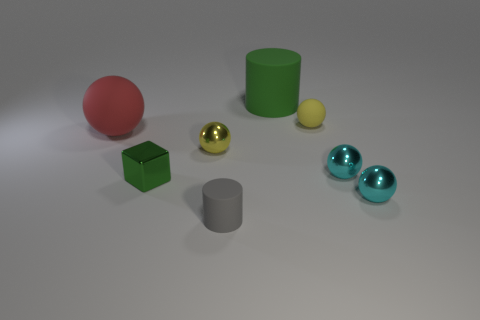Subtract all tiny cyan balls. How many balls are left? 3 Subtract all red balls. How many balls are left? 4 Add 2 gray matte cylinders. How many objects exist? 10 Subtract all green blocks. How many red spheres are left? 1 Subtract all big cyan metal blocks. Subtract all small yellow balls. How many objects are left? 6 Add 4 big green cylinders. How many big green cylinders are left? 5 Add 4 tiny cyan balls. How many tiny cyan balls exist? 6 Subtract 0 blue cylinders. How many objects are left? 8 Subtract all cubes. How many objects are left? 7 Subtract 1 balls. How many balls are left? 4 